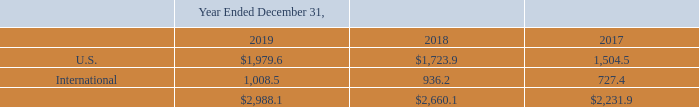18. Geographic Information
Revenue by geography is based on the customer's billing address, and was as follows:
No individual international country represented more than 10% of total revenue in any period presented.
How do they determine the geographic location of revenue earned? Based on the customer's billing address. Which 2 geographic segments are listed in the table? U.s., international. What is the U.S. revenue for year ended December 31, 2019 ? $1,979.6. What is the average U.S. revenue for 2018 and 2019? (1,979.6+1,723.9)/2
Answer: 1851.75. What is the average U.S. revenue for 2017 and 2018? (1,723.9+1,504.5)/2
Answer: 1614.2. What is the change in the average U.S. revenue between 2017-2018 and 2018-2019? [(1,979.6+1,723.9)/2] - [(1,723.9+1,504.5)/2]
Answer: 237.55. 